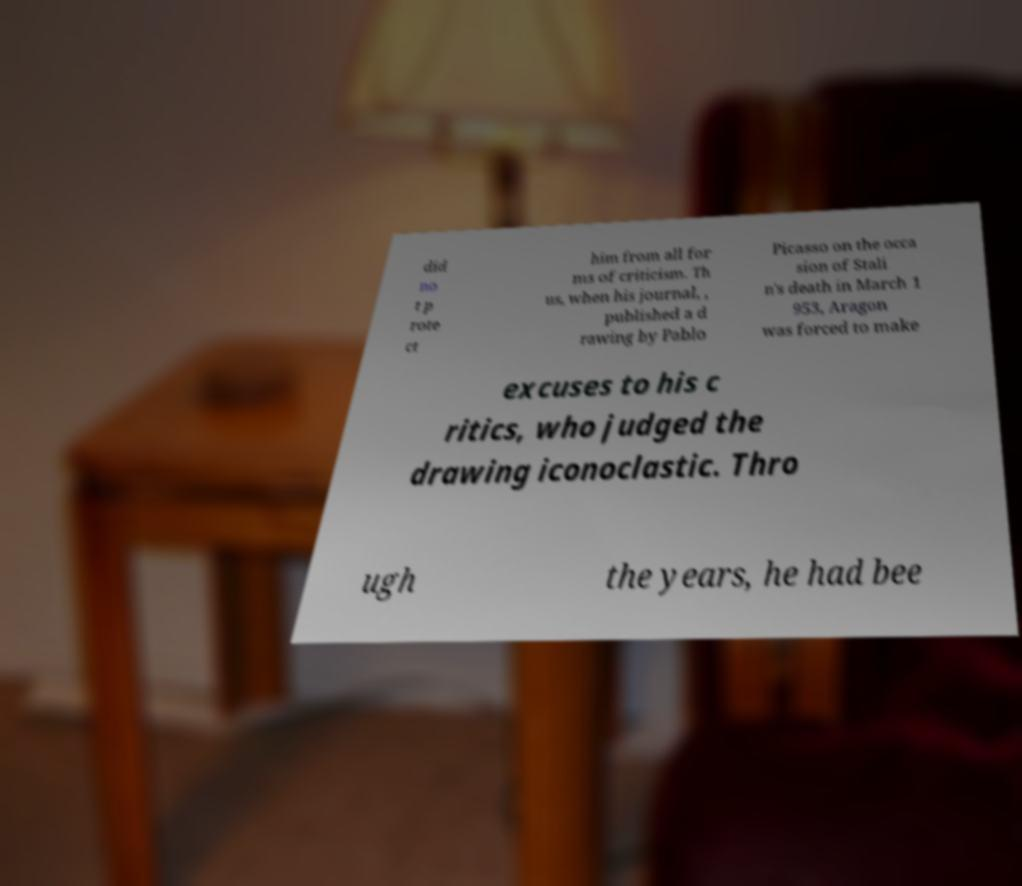Can you read and provide the text displayed in the image?This photo seems to have some interesting text. Can you extract and type it out for me? did no t p rote ct him from all for ms of criticism. Th us, when his journal, , published a d rawing by Pablo Picasso on the occa sion of Stali n's death in March 1 953, Aragon was forced to make excuses to his c ritics, who judged the drawing iconoclastic. Thro ugh the years, he had bee 